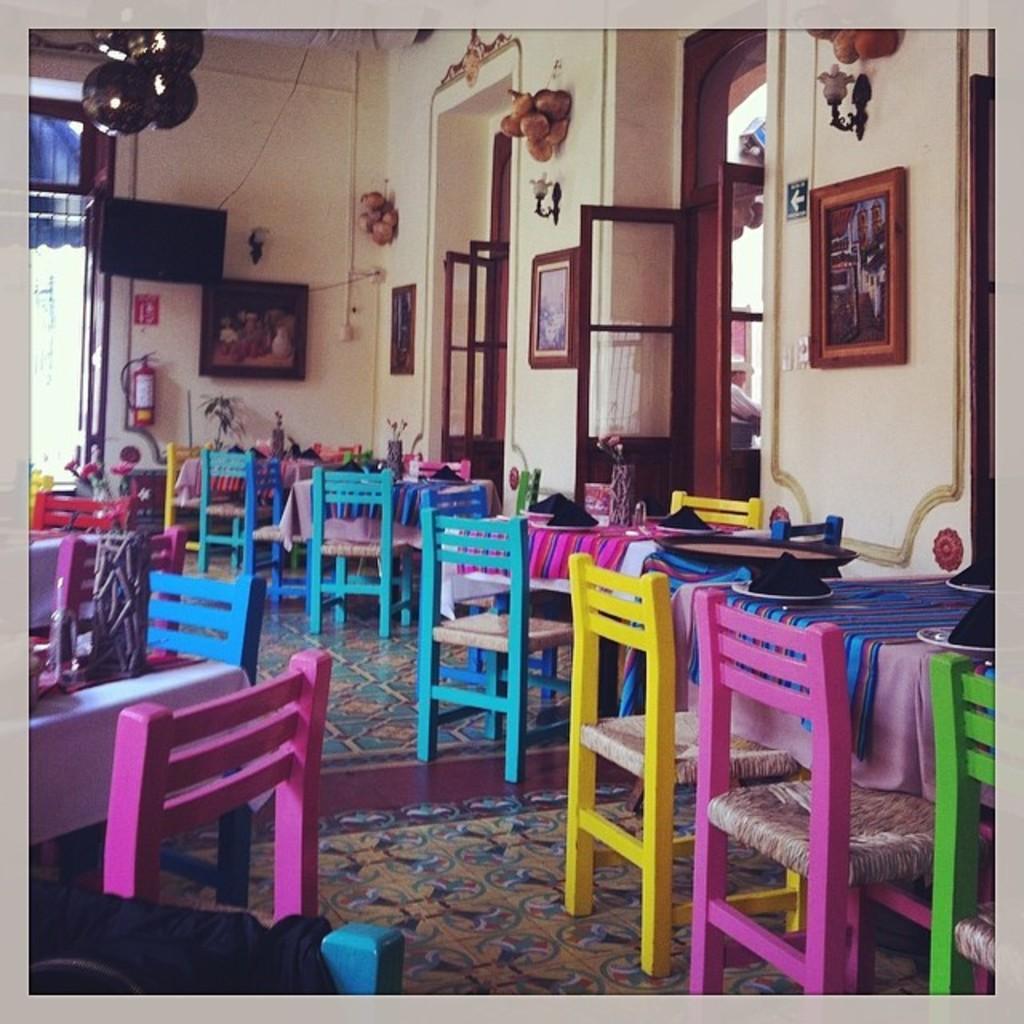Can you describe this image briefly? This picture consists of inside view of room and I can see there are colorful tables and chairs visible on the floor,on the table I can see plates and I can see the wall windows and a photo frame attached to the wall and a cylinder attached to the wall in the middle and through door I can see a person. 